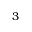Convert formula to latex. <formula><loc_0><loc_0><loc_500><loc_500>3</formula> 